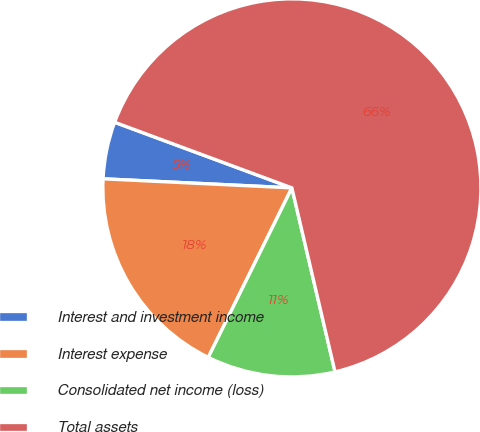Convert chart to OTSL. <chart><loc_0><loc_0><loc_500><loc_500><pie_chart><fcel>Interest and investment income<fcel>Interest expense<fcel>Consolidated net income (loss)<fcel>Total assets<nl><fcel>4.88%<fcel>18.47%<fcel>10.96%<fcel>65.69%<nl></chart> 